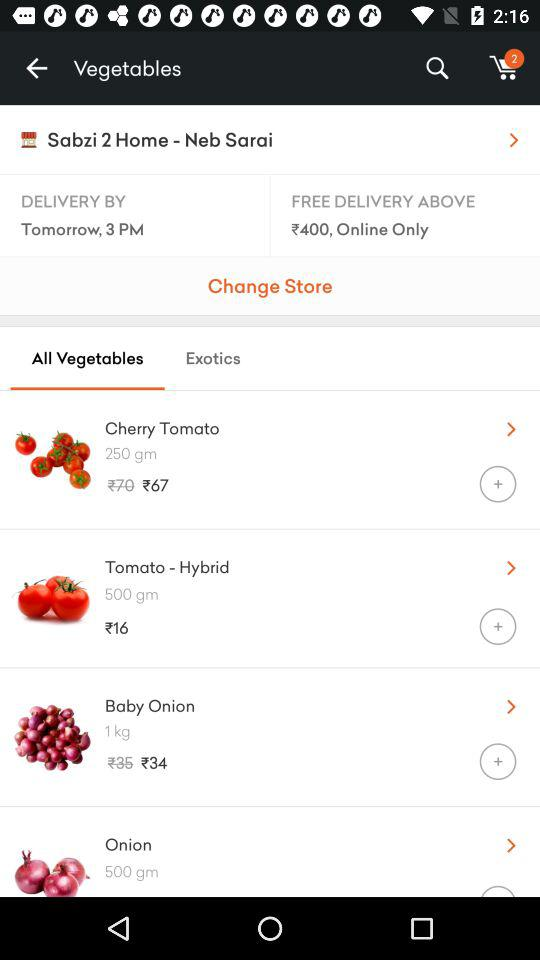What is the discounted price of "Cherry Tomato"? The discounted price of "Cherry Tomato" is ₹67. 